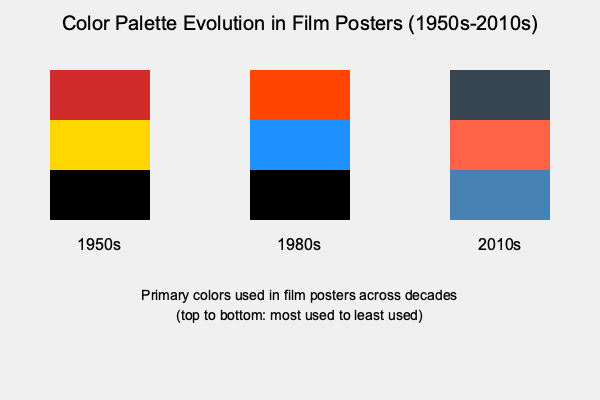Based on the color palette evolution shown in the graphic, which of the following statements best describes the trend in film poster designs from the 1950s to the 2010s?

A) Warm colors have consistently dominated across all decades
B) There's a shift from high-contrast palettes to more muted, complex color schemes
C) Blue tones have become increasingly prominent
D) Black has remained a constant primary color throughout the decades To answer this question, let's analyze the color palettes for each decade:

1. 1950s:
   - Primary colors: Red, Yellow, Black
   - Characteristics: Bold, high-contrast palette with warm tones

2. 1980s:
   - Primary colors: Orange-Red, Blue, Black
   - Characteristics: Introduction of blue, still maintaining warm tones and high contrast

3. 2010s:
   - Primary colors: Charcoal Gray, Coral, Steel Blue
   - Characteristics: More muted and complex color scheme, cooler overall palette

Analyzing the trends:

A) Warm colors have not consistently dominated. While prominent in the 1950s and 1980s, they're less dominant in the 2010s.

B) There is indeed a shift from high-contrast, bold colors (1950s) to more muted and complex color schemes (2010s). The 1980s serve as a transition period.

C) Blue tones have become more prominent, starting with their introduction in the 1980s and continuing into the 2010s with steel blue.

D) While black was a primary color in the 1950s and 1980s, it's not present in the top three colors for the 2010s, replaced by charcoal gray.

Given these observations, the statement that best describes the overall trend is option B: There's a shift from high-contrast palettes to more muted, complex color schemes.
Answer: B) There's a shift from high-contrast palettes to more muted, complex color schemes 